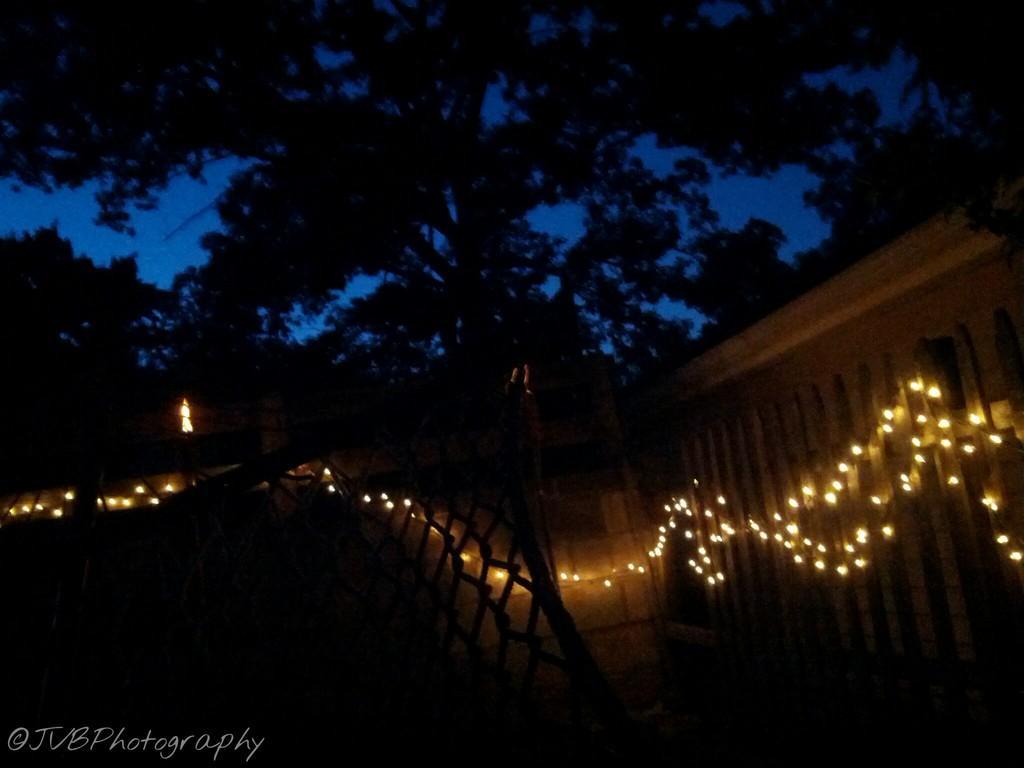Could you give a brief overview of what you see in this image? In this image there is a wall decorated with lights, behind the wall there are trees, at the bottom of the image there is text. 